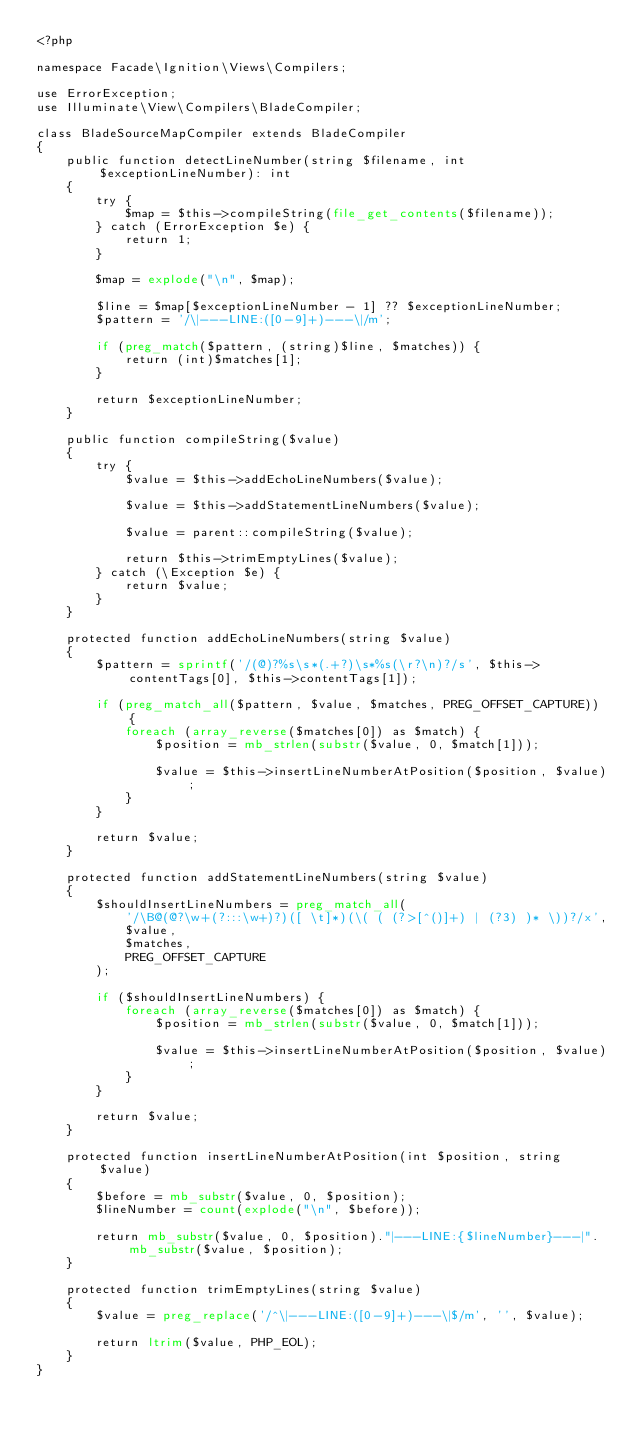Convert code to text. <code><loc_0><loc_0><loc_500><loc_500><_PHP_><?php

namespace Facade\Ignition\Views\Compilers;

use ErrorException;
use Illuminate\View\Compilers\BladeCompiler;

class BladeSourceMapCompiler extends BladeCompiler
{
    public function detectLineNumber(string $filename, int $exceptionLineNumber): int
    {
        try {
            $map = $this->compileString(file_get_contents($filename));
        } catch (ErrorException $e) {
            return 1;
        }
        
        $map = explode("\n", $map);

        $line = $map[$exceptionLineNumber - 1] ?? $exceptionLineNumber;
        $pattern = '/\|---LINE:([0-9]+)---\|/m';

        if (preg_match($pattern, (string)$line, $matches)) {
            return (int)$matches[1];
        }

        return $exceptionLineNumber;
    }

    public function compileString($value)
    {
        try {
            $value = $this->addEchoLineNumbers($value);

            $value = $this->addStatementLineNumbers($value);

            $value = parent::compileString($value);

            return $this->trimEmptyLines($value);
        } catch (\Exception $e) {
            return $value;
        }
    }

    protected function addEchoLineNumbers(string $value)
    {
        $pattern = sprintf('/(@)?%s\s*(.+?)\s*%s(\r?\n)?/s', $this->contentTags[0], $this->contentTags[1]);

        if (preg_match_all($pattern, $value, $matches, PREG_OFFSET_CAPTURE)) {
            foreach (array_reverse($matches[0]) as $match) {
                $position = mb_strlen(substr($value, 0, $match[1]));

                $value = $this->insertLineNumberAtPosition($position, $value);
            }
        }

        return $value;
    }

    protected function addStatementLineNumbers(string $value)
    {
        $shouldInsertLineNumbers = preg_match_all(
            '/\B@(@?\w+(?:::\w+)?)([ \t]*)(\( ( (?>[^()]+) | (?3) )* \))?/x',
            $value,
            $matches,
            PREG_OFFSET_CAPTURE
        );

        if ($shouldInsertLineNumbers) {
            foreach (array_reverse($matches[0]) as $match) {
                $position = mb_strlen(substr($value, 0, $match[1]));

                $value = $this->insertLineNumberAtPosition($position, $value);
            }
        }

        return $value;
    }

    protected function insertLineNumberAtPosition(int $position, string $value)
    {
        $before = mb_substr($value, 0, $position);
        $lineNumber = count(explode("\n", $before));

        return mb_substr($value, 0, $position)."|---LINE:{$lineNumber}---|".mb_substr($value, $position);
    }

    protected function trimEmptyLines(string $value)
    {
        $value = preg_replace('/^\|---LINE:([0-9]+)---\|$/m', '', $value);

        return ltrim($value, PHP_EOL);
    }
}
</code> 